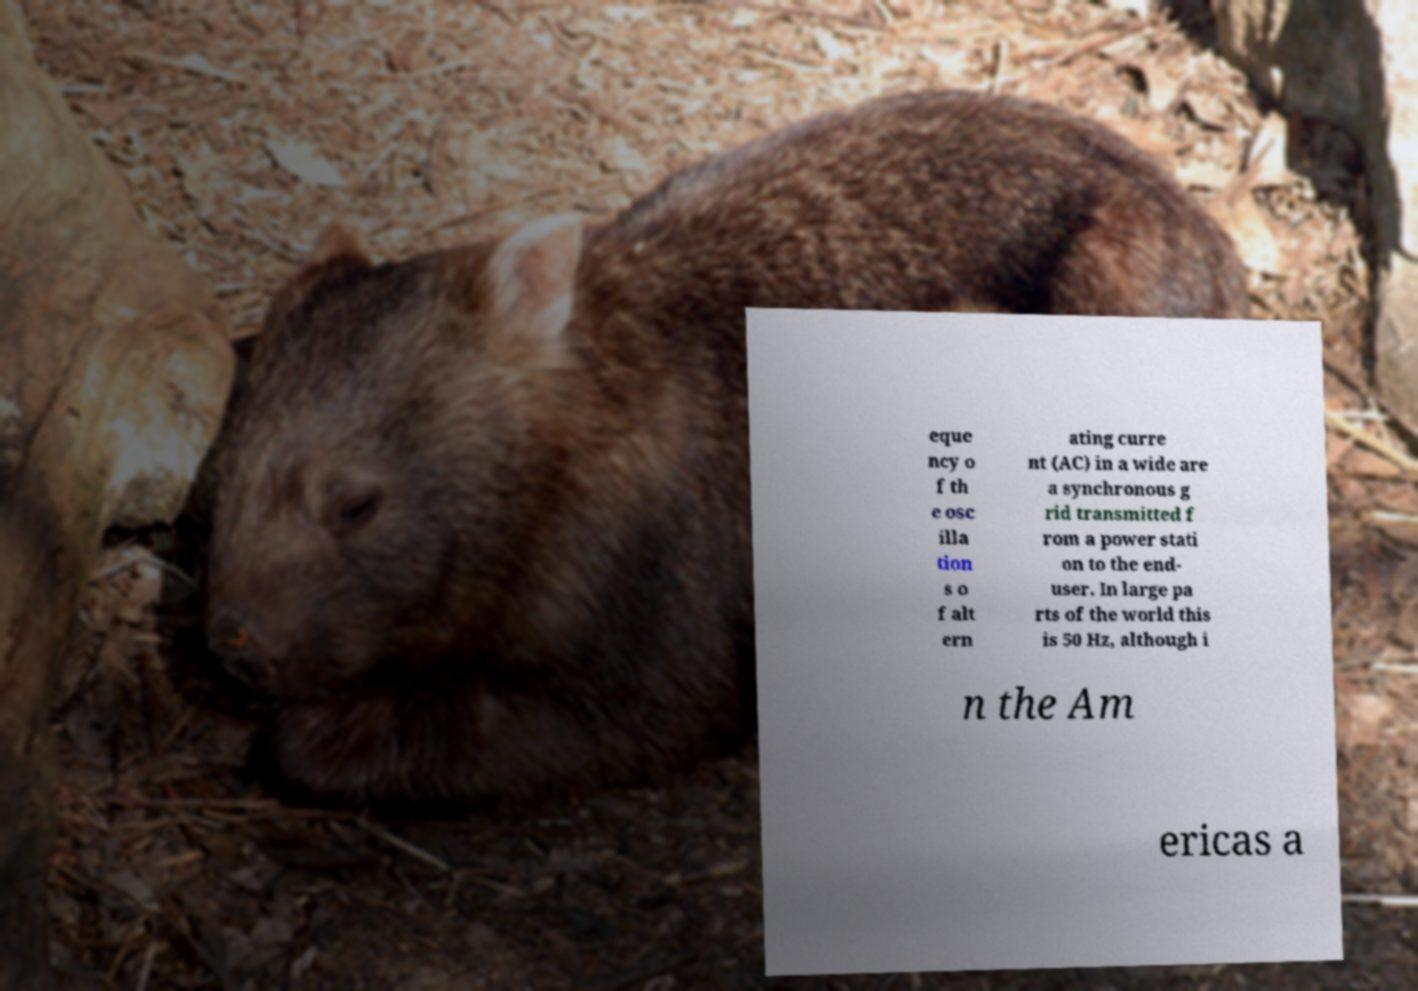I need the written content from this picture converted into text. Can you do that? eque ncy o f th e osc illa tion s o f alt ern ating curre nt (AC) in a wide are a synchronous g rid transmitted f rom a power stati on to the end- user. In large pa rts of the world this is 50 Hz, although i n the Am ericas a 